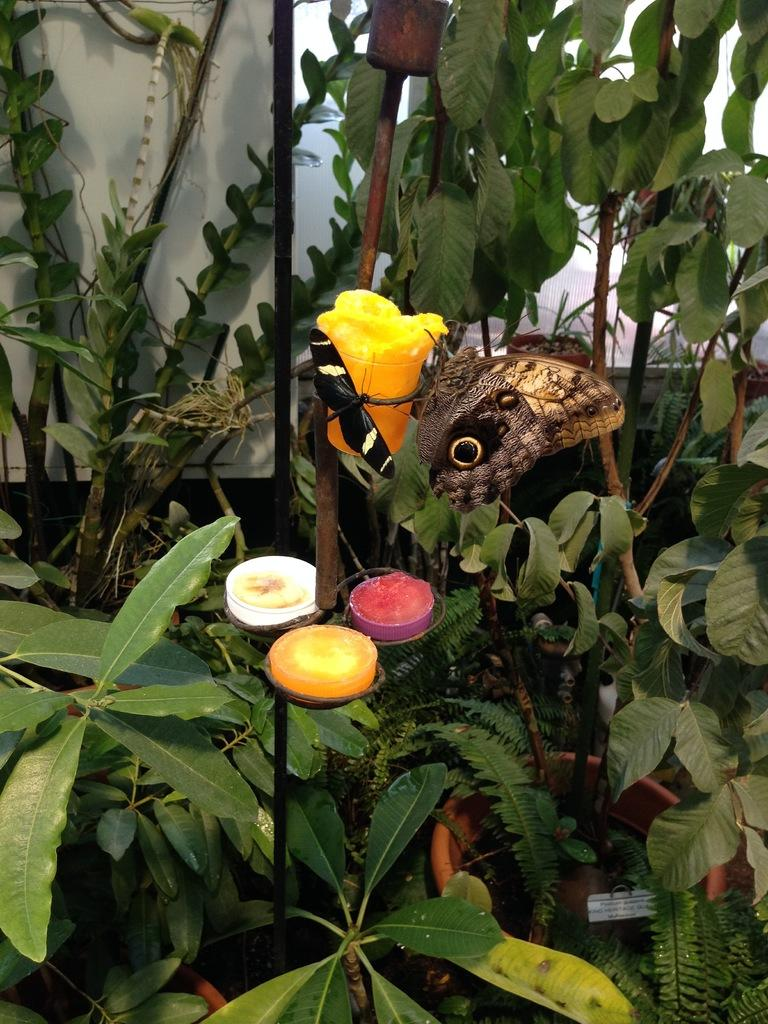How many butterflies can be seen in the image? There are two butterflies in the image. What are the butterflies resting on or near? The butterflies are on an object. What type of vegetation is present in the image? There are plants in the image. What color is the background of the image? The background of the image is white. Can you tell me the weight of the butterflies on the scale in the image? There is no scale present in the image, and therefore no weight can be determined for the butterflies. 